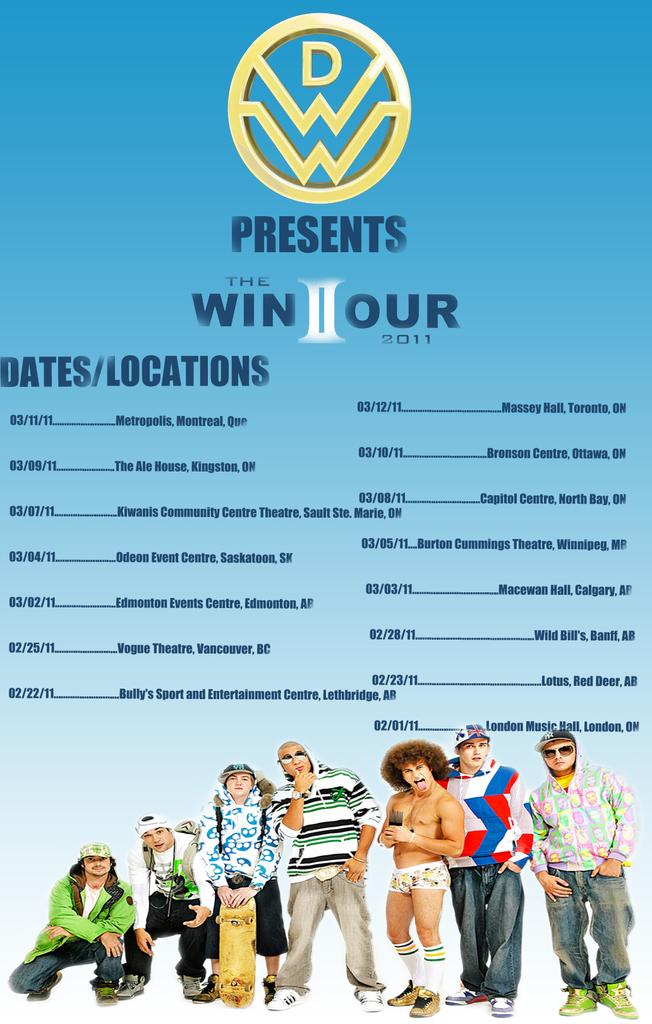What is featured on the poster in the image? The poster in the image contains text and has a logo. Can you describe the people in the image? There are people in the image, but their specific actions or characteristics are not mentioned in the provided facts. What is the purpose of the logo on the poster? The purpose of the logo on the poster is not mentioned in the provided facts. What type of field can be seen in the background of the image? There is no field present in the image; it features a poster with text and a logo. How does the passenger interact with the poster in the image? There is no passenger present in the image, so it is not possible to describe any interaction with the poster. 